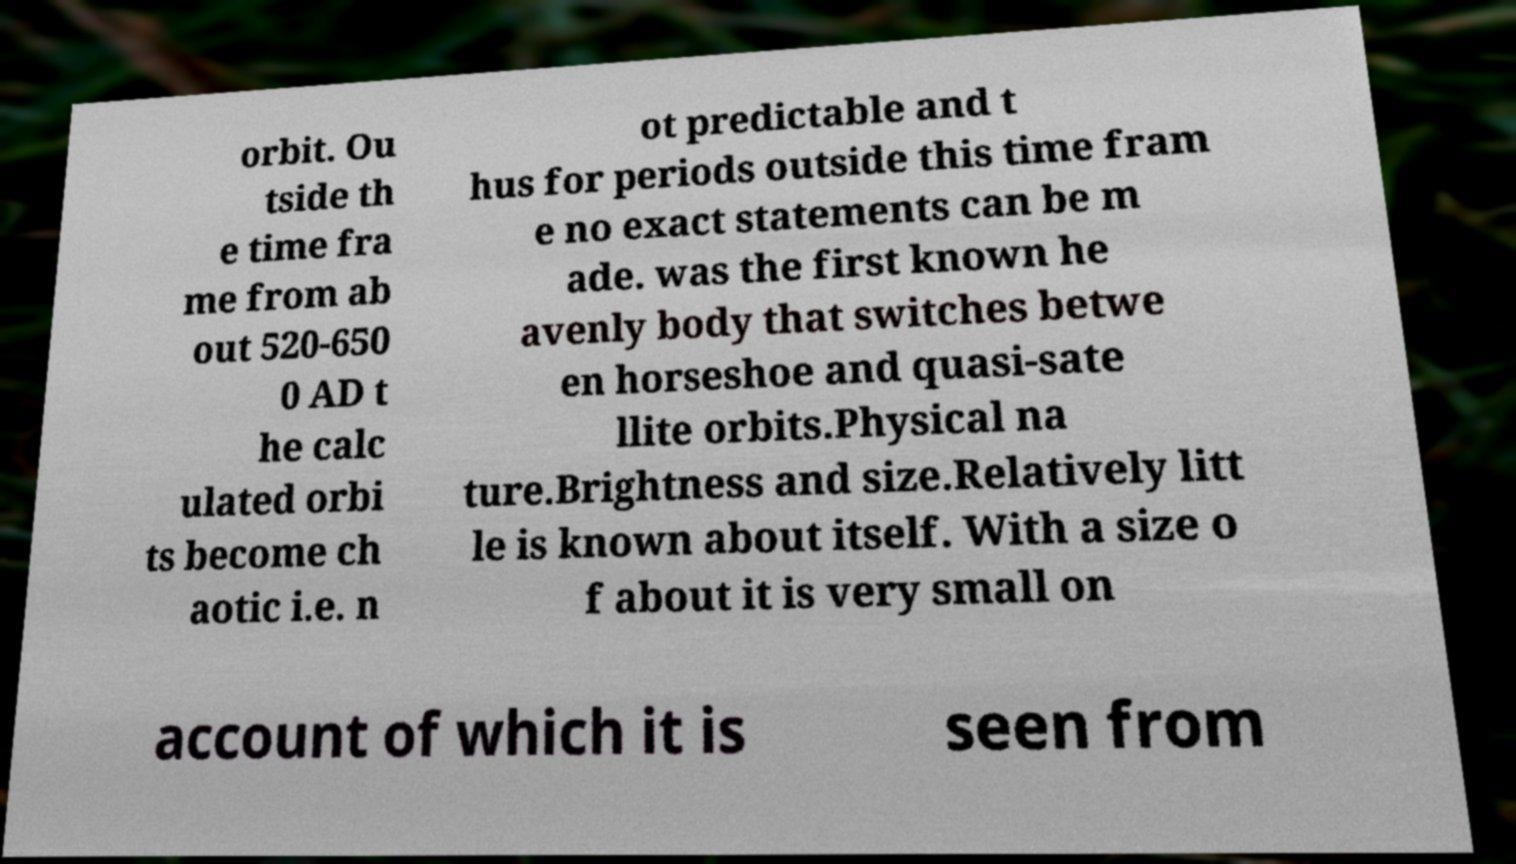Please identify and transcribe the text found in this image. orbit. Ou tside th e time fra me from ab out 520-650 0 AD t he calc ulated orbi ts become ch aotic i.e. n ot predictable and t hus for periods outside this time fram e no exact statements can be m ade. was the first known he avenly body that switches betwe en horseshoe and quasi-sate llite orbits.Physical na ture.Brightness and size.Relatively litt le is known about itself. With a size o f about it is very small on account of which it is seen from 